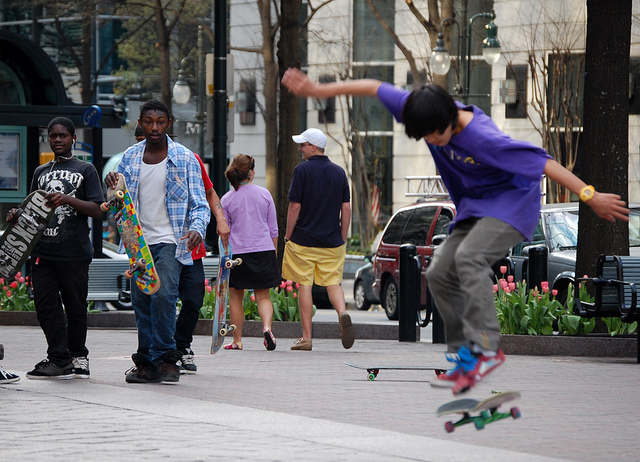Read all the text in this image. CorrupT 